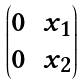Convert formula to latex. <formula><loc_0><loc_0><loc_500><loc_500>\begin{pmatrix} 0 & x _ { 1 } \\ 0 & x _ { 2 } \end{pmatrix}</formula> 